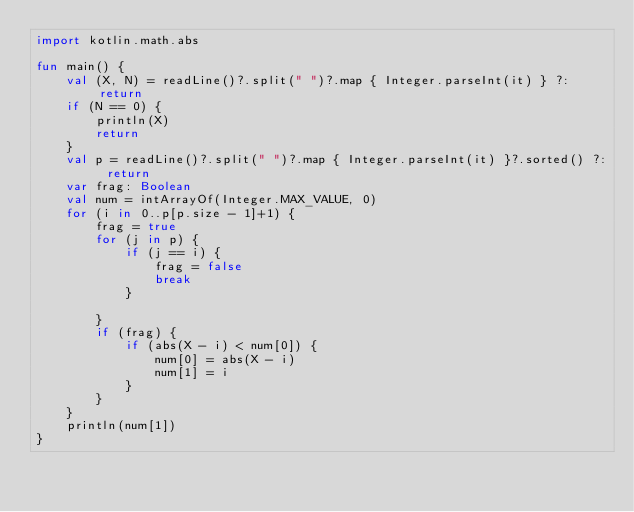Convert code to text. <code><loc_0><loc_0><loc_500><loc_500><_Kotlin_>import kotlin.math.abs

fun main() {
    val (X, N) = readLine()?.split(" ")?.map { Integer.parseInt(it) } ?: return
    if (N == 0) {
        println(X)
        return
    }
    val p = readLine()?.split(" ")?.map { Integer.parseInt(it) }?.sorted() ?: return
    var frag: Boolean
    val num = intArrayOf(Integer.MAX_VALUE, 0)
    for (i in 0..p[p.size - 1]+1) {
        frag = true
        for (j in p) {
            if (j == i) {
                frag = false
                break
            }

        }
        if (frag) {
            if (abs(X - i) < num[0]) {
                num[0] = abs(X - i)
                num[1] = i
            }
        }
    }
    println(num[1])
}</code> 